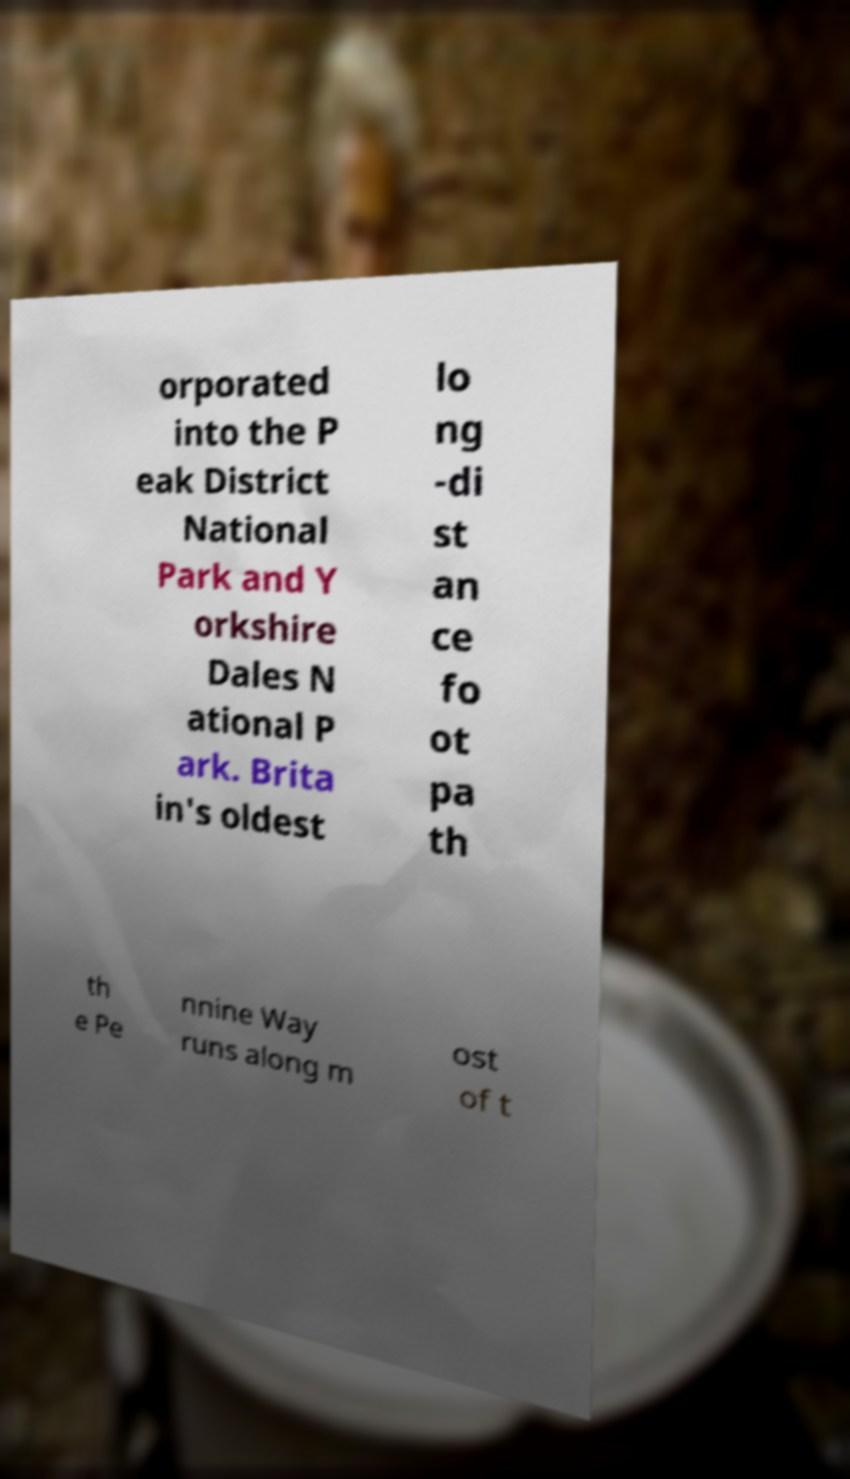Could you assist in decoding the text presented in this image and type it out clearly? orporated into the P eak District National Park and Y orkshire Dales N ational P ark. Brita in's oldest lo ng -di st an ce fo ot pa th th e Pe nnine Way runs along m ost of t 